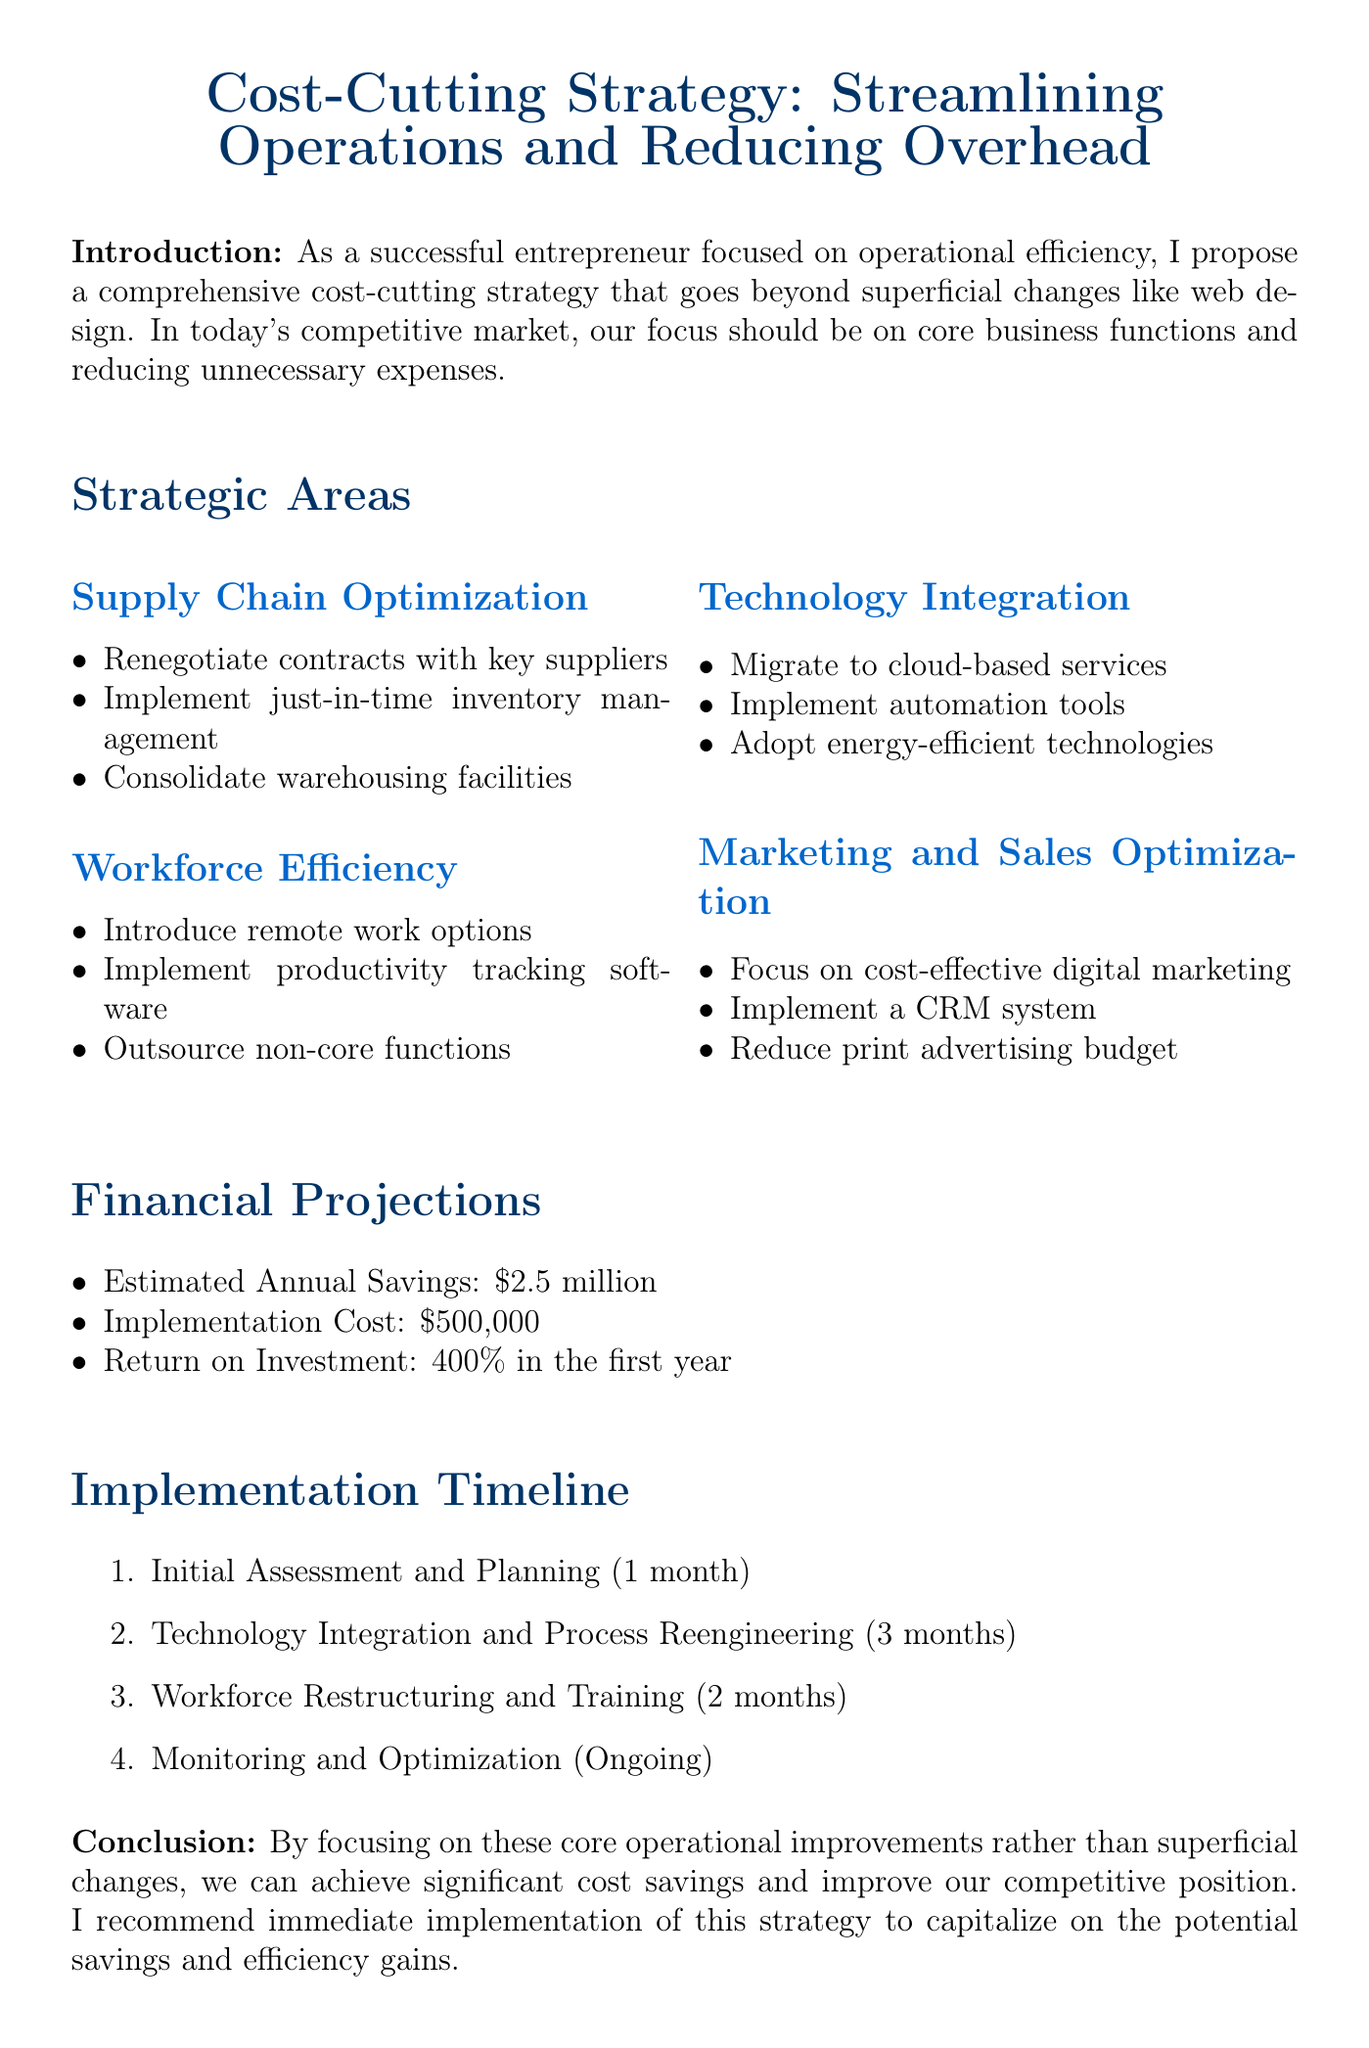What is the title of the memo? The title of the memo is presented at the top, summarizing the main focus of the document.
Answer: Cost-Cutting Strategy: Streamlining Operations and Reducing Overhead What is the estimated annual savings from the strategy? The estimated annual savings can be found under the financial projections section of the memo.
Answer: $2.5 million What phase comes after "Initial Assessment and Planning"? This question requires looking at the implementation timeline to find the sequence of phases.
Answer: Technology Integration and Process Reengineering What is the implementation cost of the strategy? This information is specified in the financial projections section, indicating the cost to implement the proposed strategy.
Answer: $500,000 How long is the "Workforce Restructuring and Training" phase? The duration of this phase is clearly stated in the implementation timeline section of the memo.
Answer: 2 months What technology is suggested for cloud migration? This requires identifying the specific service mentioned in the technology integration area of the strategic plan.
Answer: Amazon Web Services (AWS) What does the strategy aim to reduce? The main focus of the memo and its objectives are discussed in the introduction.
Answer: Overhead expenses What is the anticipated return on investment? This question can be answered based on the financial projections outlined in the memo.
Answer: 400% in the first year What software is recommended for productivity tracking? The document specifies which software tools are suggested for enhancing workforce efficiency.
Answer: Asana or Monday.com 